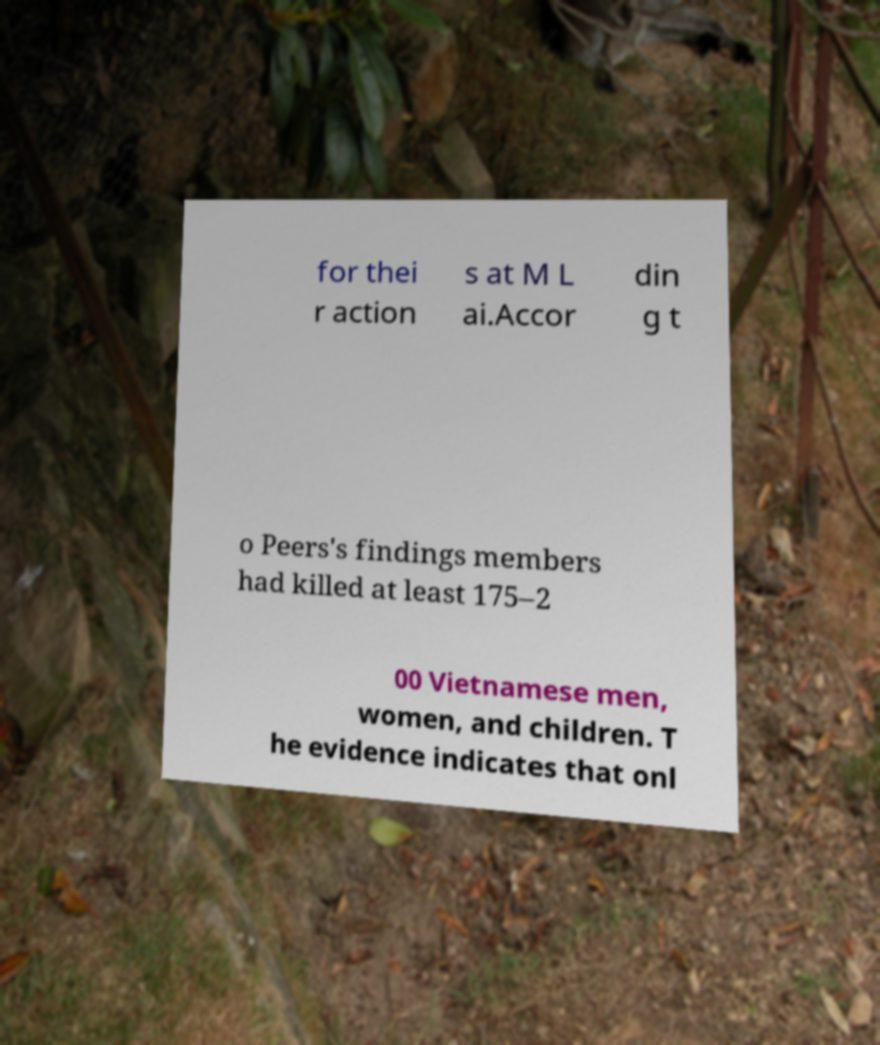For documentation purposes, I need the text within this image transcribed. Could you provide that? for thei r action s at M L ai.Accor din g t o Peers's findings members had killed at least 175–2 00 Vietnamese men, women, and children. T he evidence indicates that onl 